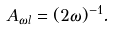Convert formula to latex. <formula><loc_0><loc_0><loc_500><loc_500>A _ { \omega l } = ( 2 \omega ) ^ { - 1 } .</formula> 